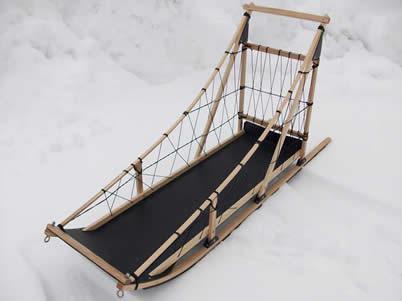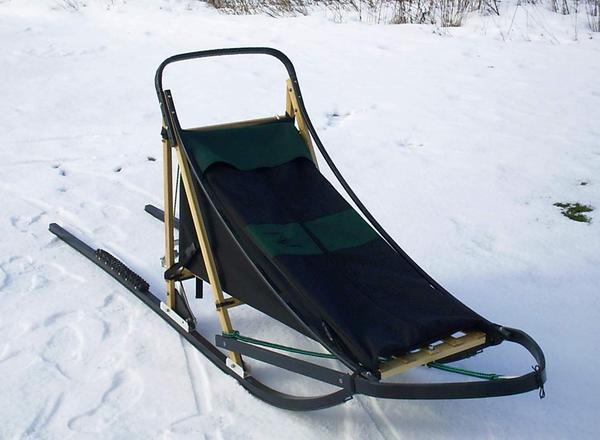The first image is the image on the left, the second image is the image on the right. Considering the images on both sides, is "There is exactly one sled in every photo, with one being made of wood with open design and black bottom and the other made with a tent material that is closed." valid? Answer yes or no. Yes. The first image is the image on the left, the second image is the image on the right. Examine the images to the left and right. Is the description "The left image contains an empty, uncovered wood-framed sled with a straight bar for a handle, netting on the sides and a black base, and the right image contains a sled with a nylon cover and curved handle." accurate? Answer yes or no. Yes. 